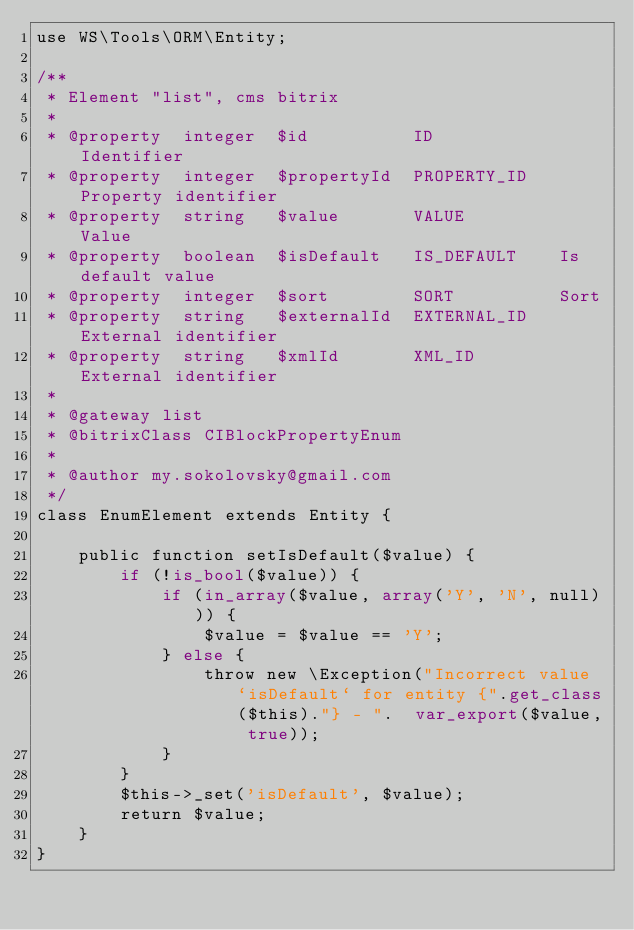<code> <loc_0><loc_0><loc_500><loc_500><_PHP_>use WS\Tools\ORM\Entity;

/**
 * Element "list", cms bitrix
 * 
 * @property  integer  $id          ID            Identifier
 * @property  integer  $propertyId  PROPERTY_ID   Property identifier
 * @property  string   $value       VALUE         Value
 * @property  boolean  $isDefault   IS_DEFAULT    Is default value
 * @property  integer  $sort        SORT          Sort
 * @property  string   $externalId  EXTERNAL_ID   External identifier
 * @property  string   $xmlId       XML_ID        External identifier
 *
 * @gateway list
 * @bitrixClass CIBlockPropertyEnum
 *
 * @author my.sokolovsky@gmail.com
 */
class EnumElement extends Entity {

    public function setIsDefault($value) {
        if (!is_bool($value)) {
            if (in_array($value, array('Y', 'N', null))) {
                $value = $value == 'Y';
            } else {
                throw new \Exception("Incorrect value `isDefault` for entity {".get_class($this)."} - ".  var_export($value, true));
            }
        }
        $this->_set('isDefault', $value);
        return $value;
    }
}
</code> 